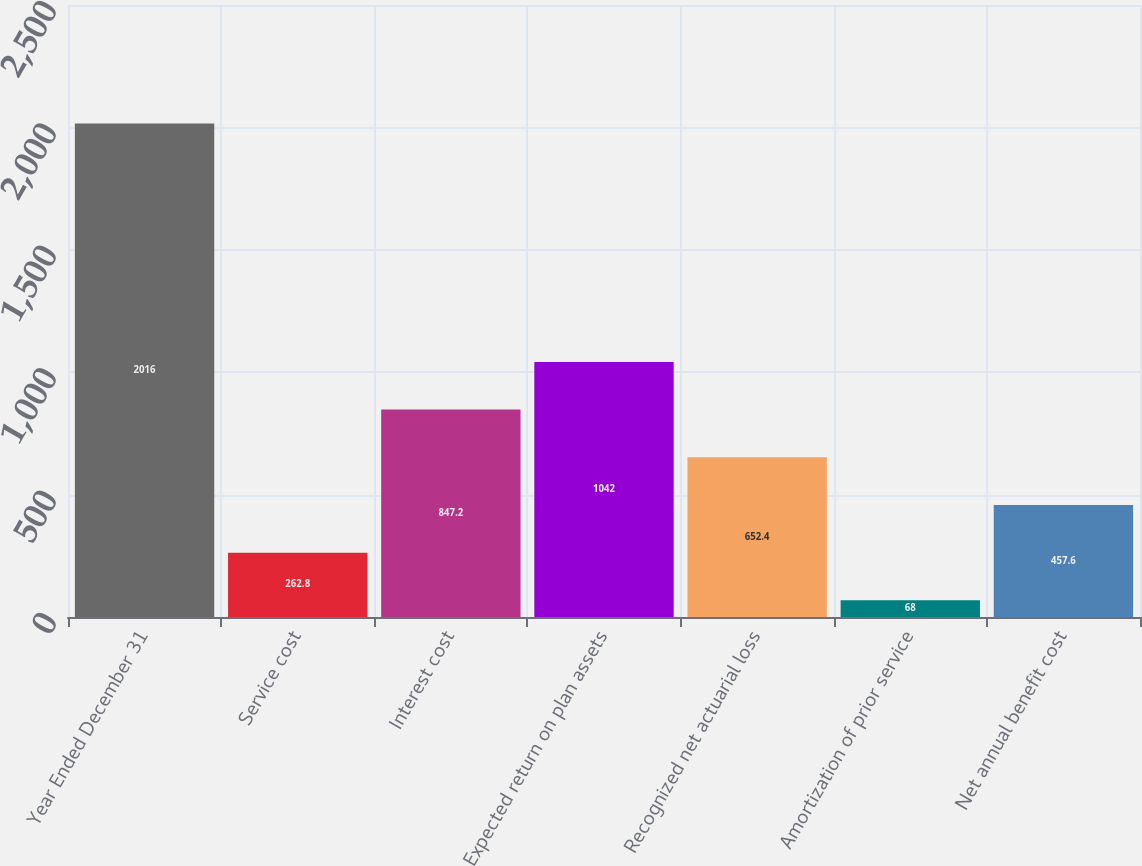<chart> <loc_0><loc_0><loc_500><loc_500><bar_chart><fcel>Year Ended December 31<fcel>Service cost<fcel>Interest cost<fcel>Expected return on plan assets<fcel>Recognized net actuarial loss<fcel>Amortization of prior service<fcel>Net annual benefit cost<nl><fcel>2016<fcel>262.8<fcel>847.2<fcel>1042<fcel>652.4<fcel>68<fcel>457.6<nl></chart> 